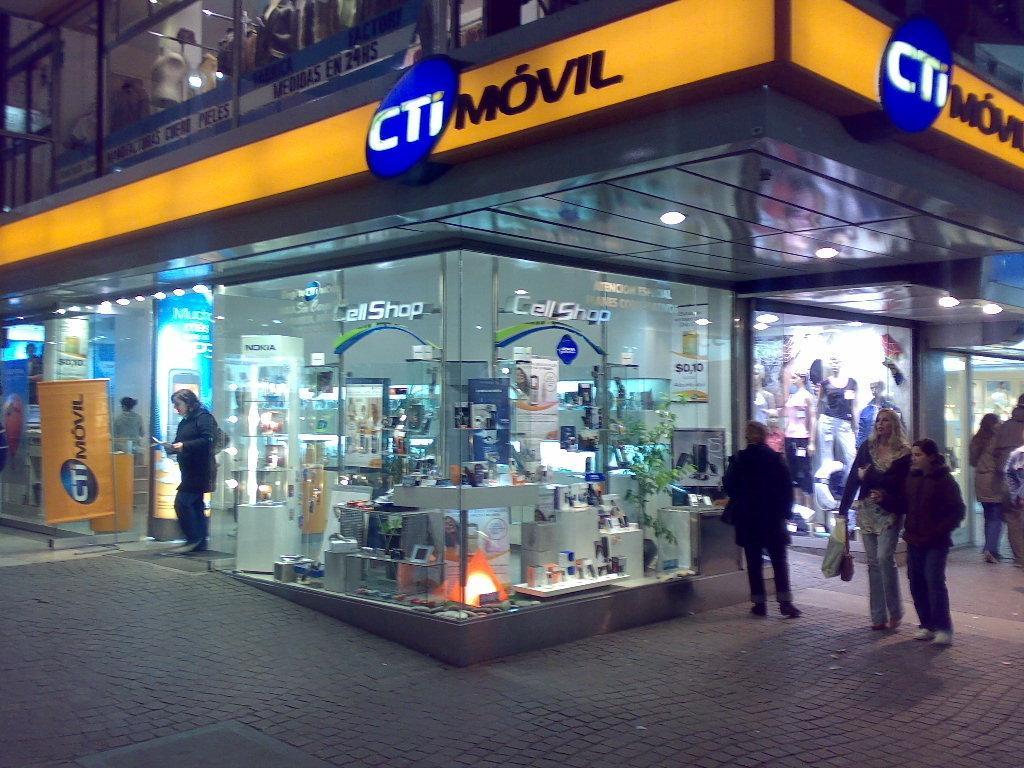How would you summarize this image in a sentence or two? In this image, we can see a cell shop and there are some people. 